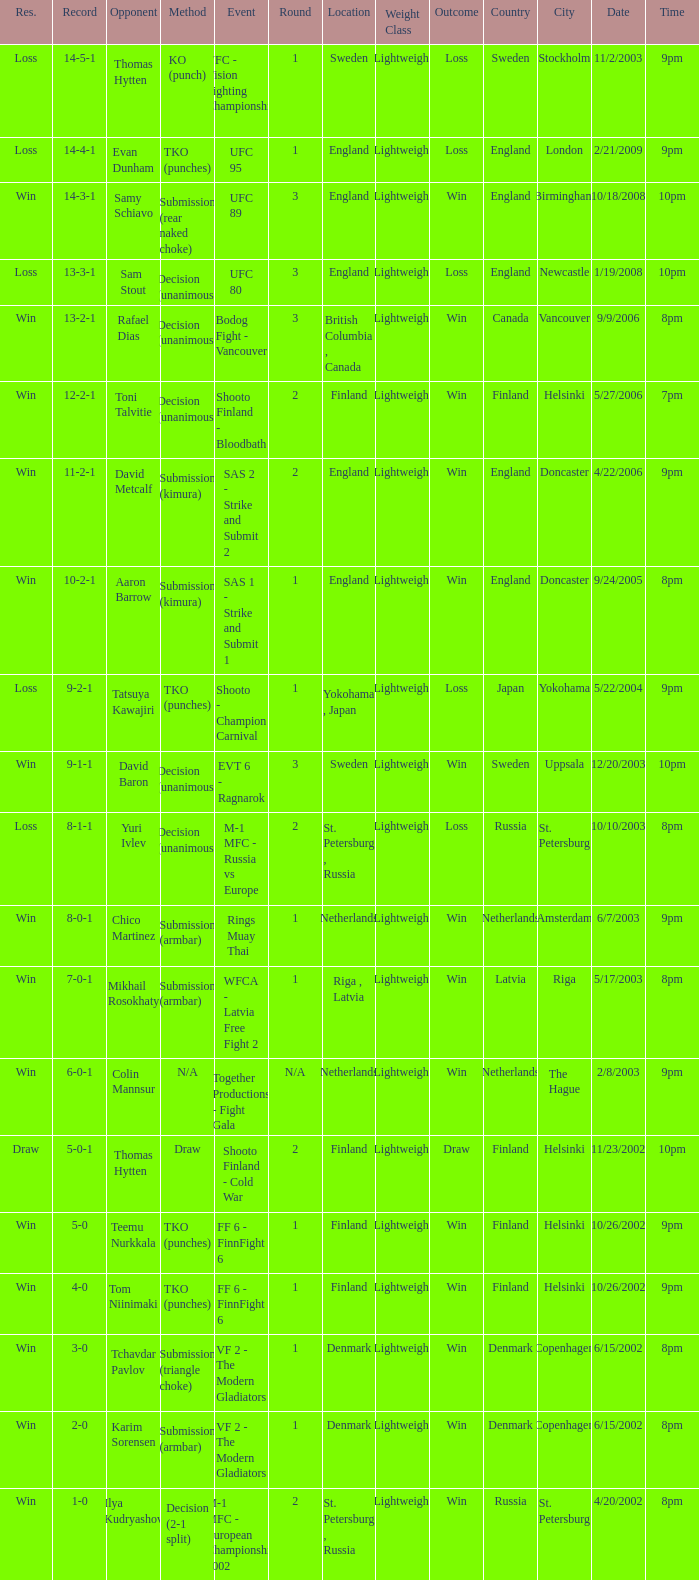What's the location when the record was 6-0-1? Netherlands. Could you help me parse every detail presented in this table? {'header': ['Res.', 'Record', 'Opponent', 'Method', 'Event', 'Round', 'Location', 'Weight Class', 'Outcome', 'Country', 'City', 'Date', 'Time'], 'rows': [['Loss', '14-5-1', 'Thomas Hytten', 'KO (punch)', 'VFC - Vision Fighting Championship 2', '1', 'Sweden', 'Lightweight', 'Loss', 'Sweden', 'Stockholm', '11/2/2003', '9pm'], ['Loss', '14-4-1', 'Evan Dunham', 'TKO (punches)', 'UFC 95', '1', 'England', 'Lightweight', 'Loss', 'England', 'London', '2/21/2009', '9pm'], ['Win', '14-3-1', 'Samy Schiavo', 'Submission (rear naked choke)', 'UFC 89', '3', 'England', 'Lightweight', 'Win', 'England', 'Birmingham', '10/18/2008', '10pm'], ['Loss', '13-3-1', 'Sam Stout', 'Decision (unanimous)', 'UFC 80', '3', 'England', 'Lightweight', 'Loss', 'England', 'Newcastle', '1/19/2008', '10pm'], ['Win', '13-2-1', 'Rafael Dias', 'Decision (unanimous)', 'Bodog Fight - Vancouver', '3', 'British Columbia , Canada', 'Lightweight', 'Win', 'Canada', 'Vancouver', '9/9/2006', '8pm'], ['Win', '12-2-1', 'Toni Talvitie', 'Decision (unanimous)', 'Shooto Finland - Bloodbath', '2', 'Finland', 'Lightweight', 'Win', 'Finland', 'Helsinki', '5/27/2006', '7pm'], ['Win', '11-2-1', 'David Metcalf', 'Submission (kimura)', 'SAS 2 - Strike and Submit 2', '2', 'England', 'Lightweight', 'Win', 'England', 'Doncaster', '4/22/2006', '9pm'], ['Win', '10-2-1', 'Aaron Barrow', 'Submission (kimura)', 'SAS 1 - Strike and Submit 1', '1', 'England', 'Lightweight', 'Win', 'England', 'Doncaster', '9/24/2005', '8pm'], ['Loss', '9-2-1', 'Tatsuya Kawajiri', 'TKO (punches)', 'Shooto - Champion Carnival', '1', 'Yokohama , Japan', 'Lightweight', 'Loss', 'Japan', 'Yokohama', '5/22/2004', '9pm'], ['Win', '9-1-1', 'David Baron', 'Decision (unanimous)', 'EVT 6 - Ragnarok', '3', 'Sweden', 'Lightweight', 'Win', 'Sweden', 'Uppsala', '12/20/2003', '10pm'], ['Loss', '8-1-1', 'Yuri Ivlev', 'Decision (unanimous)', 'M-1 MFC - Russia vs Europe', '2', 'St. Petersburg , Russia', 'Lightweight', 'Loss', 'Russia', 'St. Petersburg', '10/10/2003', '8pm'], ['Win', '8-0-1', 'Chico Martinez', 'Submission (armbar)', 'Rings Muay Thai', '1', 'Netherlands', 'Lightweight', 'Win', 'Netherlands', 'Amsterdam', '6/7/2003', '9pm'], ['Win', '7-0-1', 'Mikhail Rosokhaty', 'Submission (armbar)', 'WFCA - Latvia Free Fight 2', '1', 'Riga , Latvia', 'Lightweight', 'Win', 'Latvia', 'Riga', '5/17/2003', '8pm'], ['Win', '6-0-1', 'Colin Mannsur', 'N/A', 'Together Productions - Fight Gala', 'N/A', 'Netherlands', 'Lightweight', 'Win', 'Netherlands', 'The Hague', '2/8/2003', '9pm'], ['Draw', '5-0-1', 'Thomas Hytten', 'Draw', 'Shooto Finland - Cold War', '2', 'Finland', 'Lightweight', 'Draw', 'Finland', 'Helsinki', '11/23/2002', '10pm'], ['Win', '5-0', 'Teemu Nurkkala', 'TKO (punches)', 'FF 6 - FinnFight 6', '1', 'Finland', 'Lightweight', 'Win', 'Finland', 'Helsinki', '10/26/2002', '9pm'], ['Win', '4-0', 'Tom Niinimaki', 'TKO (punches)', 'FF 6 - FinnFight 6', '1', 'Finland', 'Lightweight', 'Win', 'Finland', 'Helsinki', '10/26/2002', '9pm'], ['Win', '3-0', 'Tchavdar Pavlov', 'Submission (triangle choke)', 'VF 2 - The Modern Gladiators', '1', 'Denmark', 'Lightweight', 'Win', 'Denmark', 'Copenhagen', '6/15/2002', '8pm'], ['Win', '2-0', 'Karim Sorensen', 'Submission (armbar)', 'VF 2 - The Modern Gladiators', '1', 'Denmark', 'Lightweight', 'Win', 'Denmark', 'Copenhagen', '6/15/2002', '8pm'], ['Win', '1-0', 'Ilya Kudryashov', 'Decision (2-1 split)', 'M-1 MFC - European Championship 2002', '2', 'St. Petersburg , Russia', 'Lightweight', 'Win', 'Russia', 'St. Petersburg', '4/20/2002', '8pm']]} 